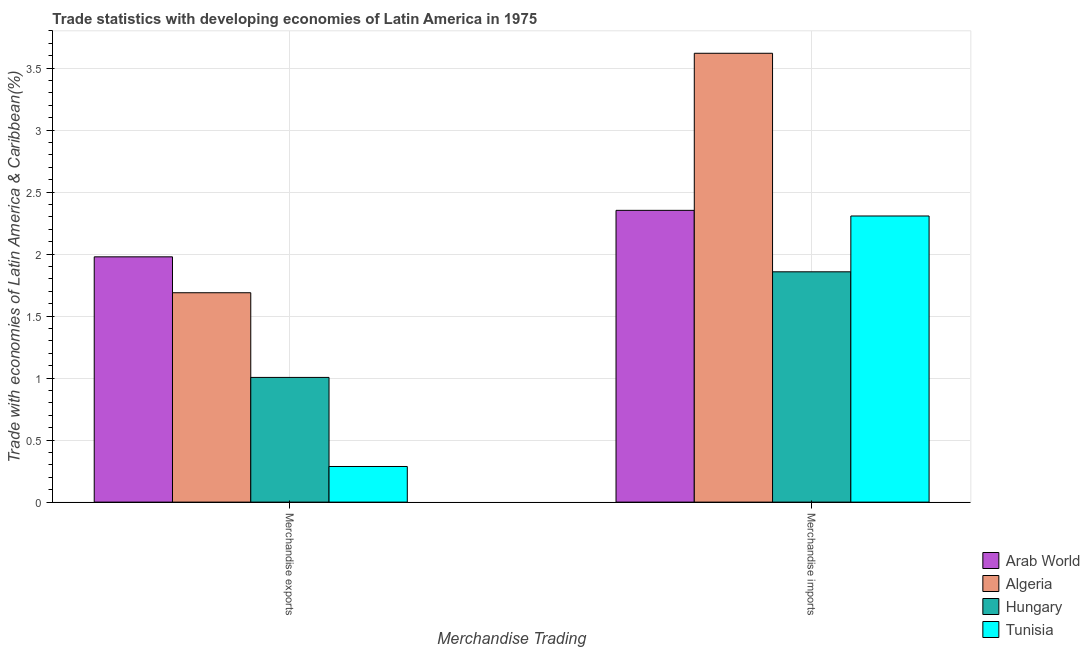How many groups of bars are there?
Keep it short and to the point. 2. Are the number of bars per tick equal to the number of legend labels?
Keep it short and to the point. Yes. Are the number of bars on each tick of the X-axis equal?
Give a very brief answer. Yes. How many bars are there on the 2nd tick from the left?
Offer a very short reply. 4. What is the label of the 1st group of bars from the left?
Offer a very short reply. Merchandise exports. What is the merchandise exports in Tunisia?
Give a very brief answer. 0.29. Across all countries, what is the maximum merchandise exports?
Keep it short and to the point. 1.98. Across all countries, what is the minimum merchandise exports?
Your answer should be very brief. 0.29. In which country was the merchandise imports maximum?
Make the answer very short. Algeria. In which country was the merchandise exports minimum?
Provide a succinct answer. Tunisia. What is the total merchandise exports in the graph?
Provide a short and direct response. 4.96. What is the difference between the merchandise exports in Algeria and that in Hungary?
Keep it short and to the point. 0.68. What is the difference between the merchandise exports in Tunisia and the merchandise imports in Algeria?
Give a very brief answer. -3.33. What is the average merchandise imports per country?
Keep it short and to the point. 2.53. What is the difference between the merchandise imports and merchandise exports in Hungary?
Offer a terse response. 0.85. What is the ratio of the merchandise exports in Arab World to that in Algeria?
Keep it short and to the point. 1.17. Is the merchandise imports in Tunisia less than that in Hungary?
Your response must be concise. No. What does the 2nd bar from the left in Merchandise exports represents?
Your response must be concise. Algeria. What does the 3rd bar from the right in Merchandise imports represents?
Offer a very short reply. Algeria. How many bars are there?
Offer a terse response. 8. Are all the bars in the graph horizontal?
Your response must be concise. No. How many countries are there in the graph?
Your response must be concise. 4. What is the difference between two consecutive major ticks on the Y-axis?
Give a very brief answer. 0.5. Does the graph contain grids?
Provide a succinct answer. Yes. What is the title of the graph?
Your response must be concise. Trade statistics with developing economies of Latin America in 1975. What is the label or title of the X-axis?
Keep it short and to the point. Merchandise Trading. What is the label or title of the Y-axis?
Provide a short and direct response. Trade with economies of Latin America & Caribbean(%). What is the Trade with economies of Latin America & Caribbean(%) of Arab World in Merchandise exports?
Make the answer very short. 1.98. What is the Trade with economies of Latin America & Caribbean(%) in Algeria in Merchandise exports?
Provide a short and direct response. 1.69. What is the Trade with economies of Latin America & Caribbean(%) of Hungary in Merchandise exports?
Offer a very short reply. 1.01. What is the Trade with economies of Latin America & Caribbean(%) of Tunisia in Merchandise exports?
Your response must be concise. 0.29. What is the Trade with economies of Latin America & Caribbean(%) of Arab World in Merchandise imports?
Give a very brief answer. 2.35. What is the Trade with economies of Latin America & Caribbean(%) of Algeria in Merchandise imports?
Offer a very short reply. 3.62. What is the Trade with economies of Latin America & Caribbean(%) in Hungary in Merchandise imports?
Keep it short and to the point. 1.86. What is the Trade with economies of Latin America & Caribbean(%) of Tunisia in Merchandise imports?
Give a very brief answer. 2.31. Across all Merchandise Trading, what is the maximum Trade with economies of Latin America & Caribbean(%) in Arab World?
Your response must be concise. 2.35. Across all Merchandise Trading, what is the maximum Trade with economies of Latin America & Caribbean(%) in Algeria?
Provide a short and direct response. 3.62. Across all Merchandise Trading, what is the maximum Trade with economies of Latin America & Caribbean(%) of Hungary?
Keep it short and to the point. 1.86. Across all Merchandise Trading, what is the maximum Trade with economies of Latin America & Caribbean(%) in Tunisia?
Give a very brief answer. 2.31. Across all Merchandise Trading, what is the minimum Trade with economies of Latin America & Caribbean(%) of Arab World?
Give a very brief answer. 1.98. Across all Merchandise Trading, what is the minimum Trade with economies of Latin America & Caribbean(%) in Algeria?
Give a very brief answer. 1.69. Across all Merchandise Trading, what is the minimum Trade with economies of Latin America & Caribbean(%) in Hungary?
Offer a very short reply. 1.01. Across all Merchandise Trading, what is the minimum Trade with economies of Latin America & Caribbean(%) of Tunisia?
Make the answer very short. 0.29. What is the total Trade with economies of Latin America & Caribbean(%) of Arab World in the graph?
Your answer should be very brief. 4.33. What is the total Trade with economies of Latin America & Caribbean(%) in Algeria in the graph?
Give a very brief answer. 5.31. What is the total Trade with economies of Latin America & Caribbean(%) of Hungary in the graph?
Your response must be concise. 2.86. What is the total Trade with economies of Latin America & Caribbean(%) in Tunisia in the graph?
Your answer should be very brief. 2.59. What is the difference between the Trade with economies of Latin America & Caribbean(%) in Arab World in Merchandise exports and that in Merchandise imports?
Make the answer very short. -0.37. What is the difference between the Trade with economies of Latin America & Caribbean(%) in Algeria in Merchandise exports and that in Merchandise imports?
Offer a terse response. -1.93. What is the difference between the Trade with economies of Latin America & Caribbean(%) in Hungary in Merchandise exports and that in Merchandise imports?
Offer a terse response. -0.85. What is the difference between the Trade with economies of Latin America & Caribbean(%) in Tunisia in Merchandise exports and that in Merchandise imports?
Ensure brevity in your answer.  -2.02. What is the difference between the Trade with economies of Latin America & Caribbean(%) of Arab World in Merchandise exports and the Trade with economies of Latin America & Caribbean(%) of Algeria in Merchandise imports?
Make the answer very short. -1.64. What is the difference between the Trade with economies of Latin America & Caribbean(%) in Arab World in Merchandise exports and the Trade with economies of Latin America & Caribbean(%) in Hungary in Merchandise imports?
Provide a short and direct response. 0.12. What is the difference between the Trade with economies of Latin America & Caribbean(%) of Arab World in Merchandise exports and the Trade with economies of Latin America & Caribbean(%) of Tunisia in Merchandise imports?
Give a very brief answer. -0.33. What is the difference between the Trade with economies of Latin America & Caribbean(%) of Algeria in Merchandise exports and the Trade with economies of Latin America & Caribbean(%) of Hungary in Merchandise imports?
Make the answer very short. -0.17. What is the difference between the Trade with economies of Latin America & Caribbean(%) in Algeria in Merchandise exports and the Trade with economies of Latin America & Caribbean(%) in Tunisia in Merchandise imports?
Give a very brief answer. -0.62. What is the difference between the Trade with economies of Latin America & Caribbean(%) of Hungary in Merchandise exports and the Trade with economies of Latin America & Caribbean(%) of Tunisia in Merchandise imports?
Offer a terse response. -1.3. What is the average Trade with economies of Latin America & Caribbean(%) in Arab World per Merchandise Trading?
Offer a terse response. 2.17. What is the average Trade with economies of Latin America & Caribbean(%) in Algeria per Merchandise Trading?
Provide a short and direct response. 2.65. What is the average Trade with economies of Latin America & Caribbean(%) of Hungary per Merchandise Trading?
Provide a succinct answer. 1.43. What is the average Trade with economies of Latin America & Caribbean(%) of Tunisia per Merchandise Trading?
Provide a succinct answer. 1.3. What is the difference between the Trade with economies of Latin America & Caribbean(%) of Arab World and Trade with economies of Latin America & Caribbean(%) of Algeria in Merchandise exports?
Provide a short and direct response. 0.29. What is the difference between the Trade with economies of Latin America & Caribbean(%) in Arab World and Trade with economies of Latin America & Caribbean(%) in Hungary in Merchandise exports?
Provide a succinct answer. 0.97. What is the difference between the Trade with economies of Latin America & Caribbean(%) in Arab World and Trade with economies of Latin America & Caribbean(%) in Tunisia in Merchandise exports?
Ensure brevity in your answer.  1.69. What is the difference between the Trade with economies of Latin America & Caribbean(%) of Algeria and Trade with economies of Latin America & Caribbean(%) of Hungary in Merchandise exports?
Your answer should be compact. 0.68. What is the difference between the Trade with economies of Latin America & Caribbean(%) of Algeria and Trade with economies of Latin America & Caribbean(%) of Tunisia in Merchandise exports?
Provide a short and direct response. 1.4. What is the difference between the Trade with economies of Latin America & Caribbean(%) of Hungary and Trade with economies of Latin America & Caribbean(%) of Tunisia in Merchandise exports?
Your answer should be very brief. 0.72. What is the difference between the Trade with economies of Latin America & Caribbean(%) in Arab World and Trade with economies of Latin America & Caribbean(%) in Algeria in Merchandise imports?
Offer a terse response. -1.27. What is the difference between the Trade with economies of Latin America & Caribbean(%) of Arab World and Trade with economies of Latin America & Caribbean(%) of Hungary in Merchandise imports?
Make the answer very short. 0.5. What is the difference between the Trade with economies of Latin America & Caribbean(%) of Arab World and Trade with economies of Latin America & Caribbean(%) of Tunisia in Merchandise imports?
Your answer should be very brief. 0.05. What is the difference between the Trade with economies of Latin America & Caribbean(%) in Algeria and Trade with economies of Latin America & Caribbean(%) in Hungary in Merchandise imports?
Your answer should be compact. 1.76. What is the difference between the Trade with economies of Latin America & Caribbean(%) of Algeria and Trade with economies of Latin America & Caribbean(%) of Tunisia in Merchandise imports?
Offer a very short reply. 1.31. What is the difference between the Trade with economies of Latin America & Caribbean(%) in Hungary and Trade with economies of Latin America & Caribbean(%) in Tunisia in Merchandise imports?
Make the answer very short. -0.45. What is the ratio of the Trade with economies of Latin America & Caribbean(%) of Arab World in Merchandise exports to that in Merchandise imports?
Make the answer very short. 0.84. What is the ratio of the Trade with economies of Latin America & Caribbean(%) of Algeria in Merchandise exports to that in Merchandise imports?
Make the answer very short. 0.47. What is the ratio of the Trade with economies of Latin America & Caribbean(%) in Hungary in Merchandise exports to that in Merchandise imports?
Your answer should be very brief. 0.54. What is the ratio of the Trade with economies of Latin America & Caribbean(%) in Tunisia in Merchandise exports to that in Merchandise imports?
Give a very brief answer. 0.12. What is the difference between the highest and the second highest Trade with economies of Latin America & Caribbean(%) of Arab World?
Ensure brevity in your answer.  0.37. What is the difference between the highest and the second highest Trade with economies of Latin America & Caribbean(%) of Algeria?
Provide a short and direct response. 1.93. What is the difference between the highest and the second highest Trade with economies of Latin America & Caribbean(%) of Hungary?
Provide a succinct answer. 0.85. What is the difference between the highest and the second highest Trade with economies of Latin America & Caribbean(%) of Tunisia?
Your answer should be compact. 2.02. What is the difference between the highest and the lowest Trade with economies of Latin America & Caribbean(%) in Arab World?
Give a very brief answer. 0.37. What is the difference between the highest and the lowest Trade with economies of Latin America & Caribbean(%) in Algeria?
Your response must be concise. 1.93. What is the difference between the highest and the lowest Trade with economies of Latin America & Caribbean(%) in Hungary?
Your answer should be compact. 0.85. What is the difference between the highest and the lowest Trade with economies of Latin America & Caribbean(%) in Tunisia?
Offer a terse response. 2.02. 